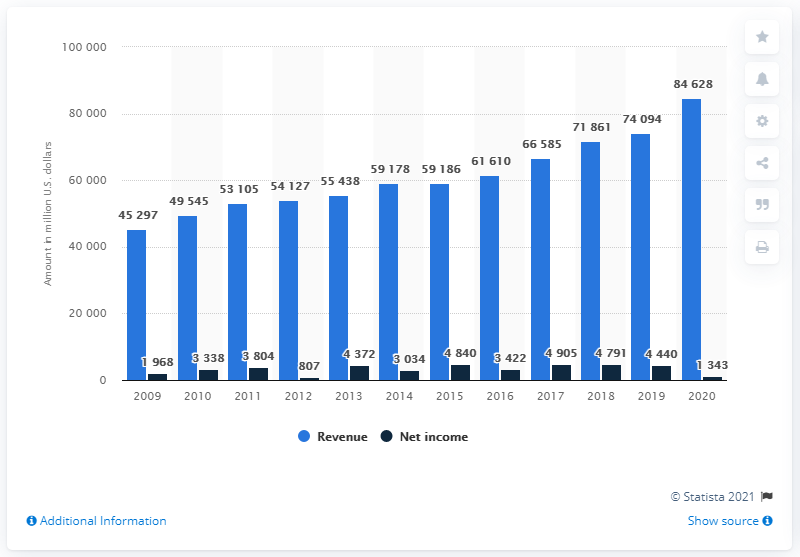Outline some significant characteristics in this image. In 2021, the United Parcel Service generated a total revenue of 84,628 U.S. dollars in the United States. 